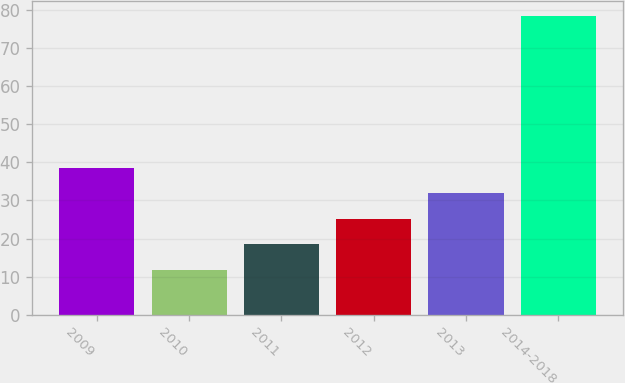Convert chart. <chart><loc_0><loc_0><loc_500><loc_500><bar_chart><fcel>2009<fcel>2010<fcel>2011<fcel>2012<fcel>2013<fcel>2014-2018<nl><fcel>38.52<fcel>11.8<fcel>18.48<fcel>25.16<fcel>31.84<fcel>78.6<nl></chart> 